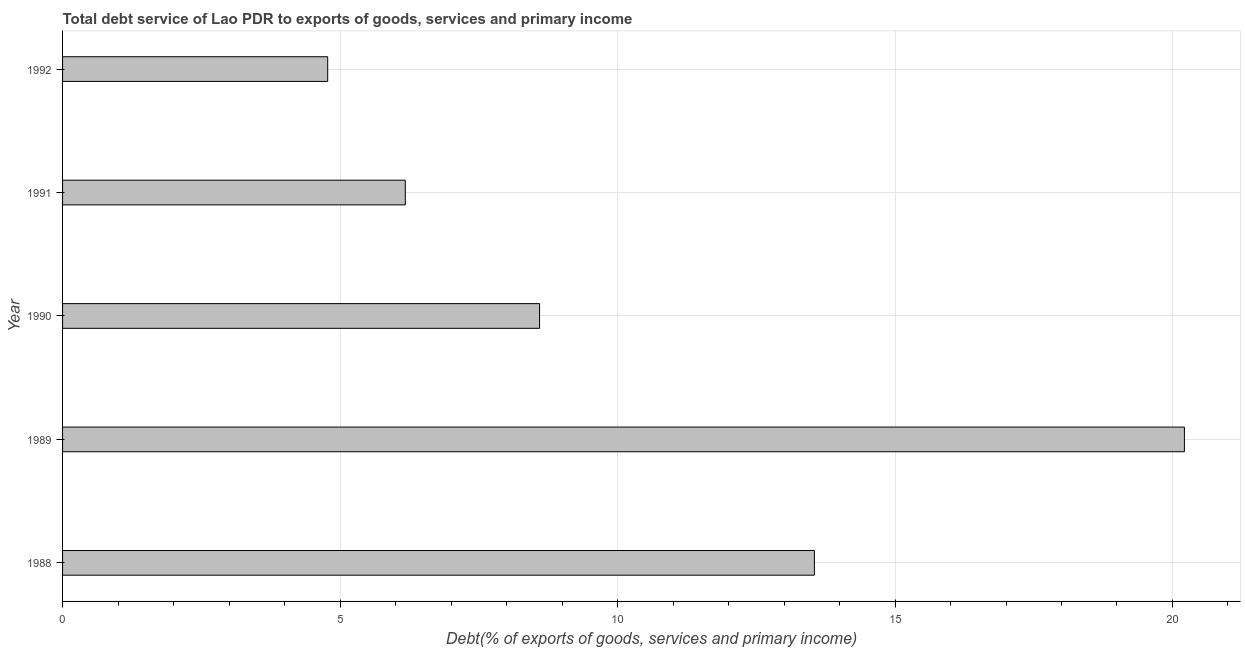Does the graph contain grids?
Your response must be concise. Yes. What is the title of the graph?
Ensure brevity in your answer.  Total debt service of Lao PDR to exports of goods, services and primary income. What is the label or title of the X-axis?
Your response must be concise. Debt(% of exports of goods, services and primary income). What is the total debt service in 1989?
Offer a terse response. 20.21. Across all years, what is the maximum total debt service?
Your response must be concise. 20.21. Across all years, what is the minimum total debt service?
Offer a very short reply. 4.78. What is the sum of the total debt service?
Provide a short and direct response. 53.31. What is the difference between the total debt service in 1988 and 1992?
Your response must be concise. 8.77. What is the average total debt service per year?
Your response must be concise. 10.66. What is the median total debt service?
Give a very brief answer. 8.6. In how many years, is the total debt service greater than 16 %?
Your answer should be very brief. 1. Do a majority of the years between 1988 and 1989 (inclusive) have total debt service greater than 17 %?
Your answer should be compact. No. What is the ratio of the total debt service in 1990 to that in 1991?
Make the answer very short. 1.39. What is the difference between the highest and the second highest total debt service?
Your response must be concise. 6.67. Is the sum of the total debt service in 1988 and 1990 greater than the maximum total debt service across all years?
Provide a short and direct response. Yes. What is the difference between the highest and the lowest total debt service?
Your answer should be compact. 15.44. How many bars are there?
Provide a short and direct response. 5. Are all the bars in the graph horizontal?
Make the answer very short. Yes. What is the difference between two consecutive major ticks on the X-axis?
Ensure brevity in your answer.  5. Are the values on the major ticks of X-axis written in scientific E-notation?
Give a very brief answer. No. What is the Debt(% of exports of goods, services and primary income) in 1988?
Ensure brevity in your answer.  13.55. What is the Debt(% of exports of goods, services and primary income) in 1989?
Provide a short and direct response. 20.21. What is the Debt(% of exports of goods, services and primary income) of 1990?
Keep it short and to the point. 8.6. What is the Debt(% of exports of goods, services and primary income) of 1991?
Your response must be concise. 6.18. What is the Debt(% of exports of goods, services and primary income) in 1992?
Your response must be concise. 4.78. What is the difference between the Debt(% of exports of goods, services and primary income) in 1988 and 1989?
Provide a short and direct response. -6.67. What is the difference between the Debt(% of exports of goods, services and primary income) in 1988 and 1990?
Offer a terse response. 4.95. What is the difference between the Debt(% of exports of goods, services and primary income) in 1988 and 1991?
Make the answer very short. 7.37. What is the difference between the Debt(% of exports of goods, services and primary income) in 1988 and 1992?
Provide a succinct answer. 8.77. What is the difference between the Debt(% of exports of goods, services and primary income) in 1989 and 1990?
Your answer should be very brief. 11.62. What is the difference between the Debt(% of exports of goods, services and primary income) in 1989 and 1991?
Keep it short and to the point. 14.04. What is the difference between the Debt(% of exports of goods, services and primary income) in 1989 and 1992?
Provide a short and direct response. 15.44. What is the difference between the Debt(% of exports of goods, services and primary income) in 1990 and 1991?
Offer a terse response. 2.42. What is the difference between the Debt(% of exports of goods, services and primary income) in 1990 and 1992?
Offer a terse response. 3.82. What is the difference between the Debt(% of exports of goods, services and primary income) in 1991 and 1992?
Provide a short and direct response. 1.4. What is the ratio of the Debt(% of exports of goods, services and primary income) in 1988 to that in 1989?
Your answer should be very brief. 0.67. What is the ratio of the Debt(% of exports of goods, services and primary income) in 1988 to that in 1990?
Provide a succinct answer. 1.58. What is the ratio of the Debt(% of exports of goods, services and primary income) in 1988 to that in 1991?
Your answer should be compact. 2.19. What is the ratio of the Debt(% of exports of goods, services and primary income) in 1988 to that in 1992?
Make the answer very short. 2.84. What is the ratio of the Debt(% of exports of goods, services and primary income) in 1989 to that in 1990?
Ensure brevity in your answer.  2.35. What is the ratio of the Debt(% of exports of goods, services and primary income) in 1989 to that in 1991?
Offer a very short reply. 3.27. What is the ratio of the Debt(% of exports of goods, services and primary income) in 1989 to that in 1992?
Your answer should be compact. 4.23. What is the ratio of the Debt(% of exports of goods, services and primary income) in 1990 to that in 1991?
Your answer should be compact. 1.39. What is the ratio of the Debt(% of exports of goods, services and primary income) in 1990 to that in 1992?
Provide a short and direct response. 1.8. What is the ratio of the Debt(% of exports of goods, services and primary income) in 1991 to that in 1992?
Provide a short and direct response. 1.29. 